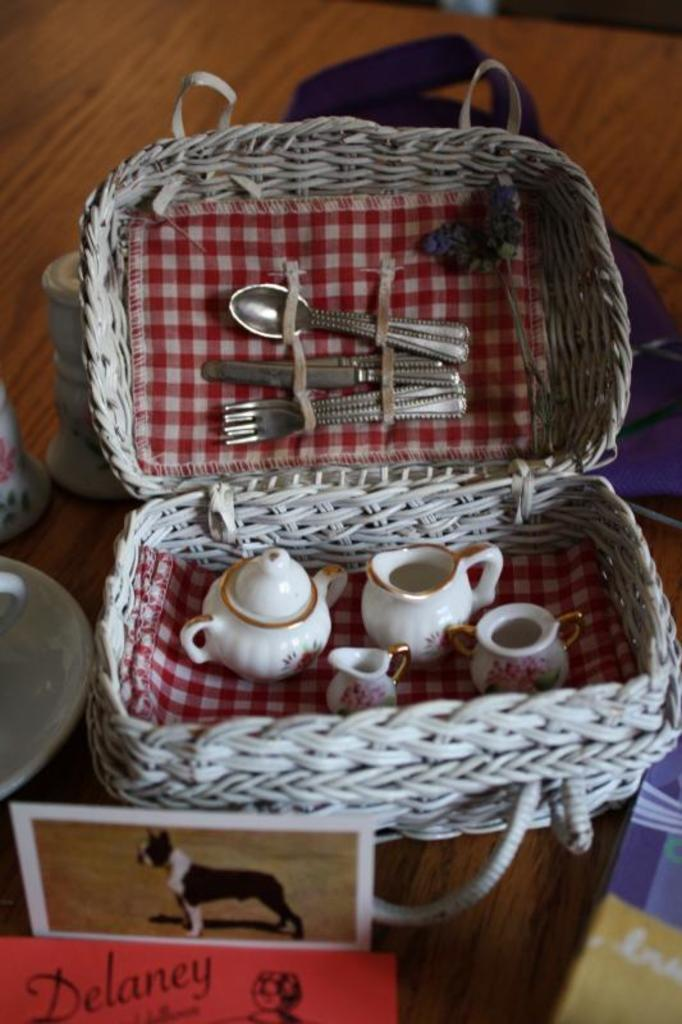What utensils are visible in the image? There are spoons in the image. What type of containers are present in the image? There are jars in the image. How are the jars arranged or organized? The jars are in a white color basket. What is another item visible on the table? There is a plate in the image. What type of surface is the plate and jars resting on? There are boards in the image. What is the color of the table where the objects are placed? The objects are on a brown color table. How many bears can be seen playing with quartz on the table in the image? There are no bears or quartz present in the image. What type of light source is illuminating the objects on the table in the image? The image does not provide information about a light source; it only shows the objects on the table. 